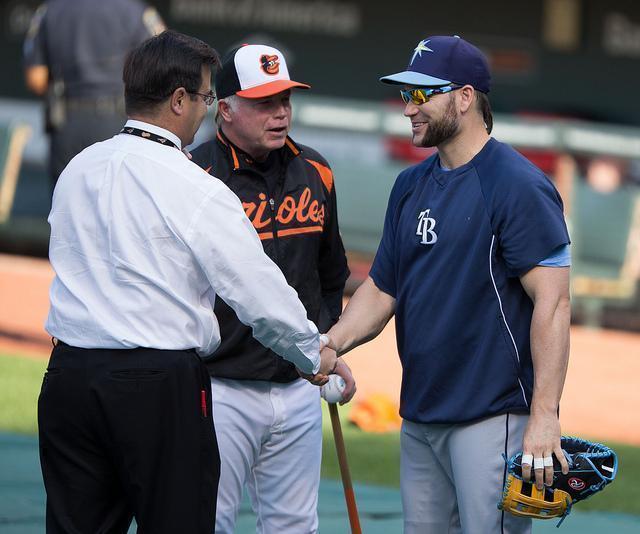Why are the men shaking hands?
Select the correct answer and articulate reasoning with the following format: 'Answer: answer
Rationale: rationale.'
Options: Baseball rule, being friendly, sportsmanship, distraction. Answer: sportsmanship.
Rationale: They seems to be getting along and being friendly. 